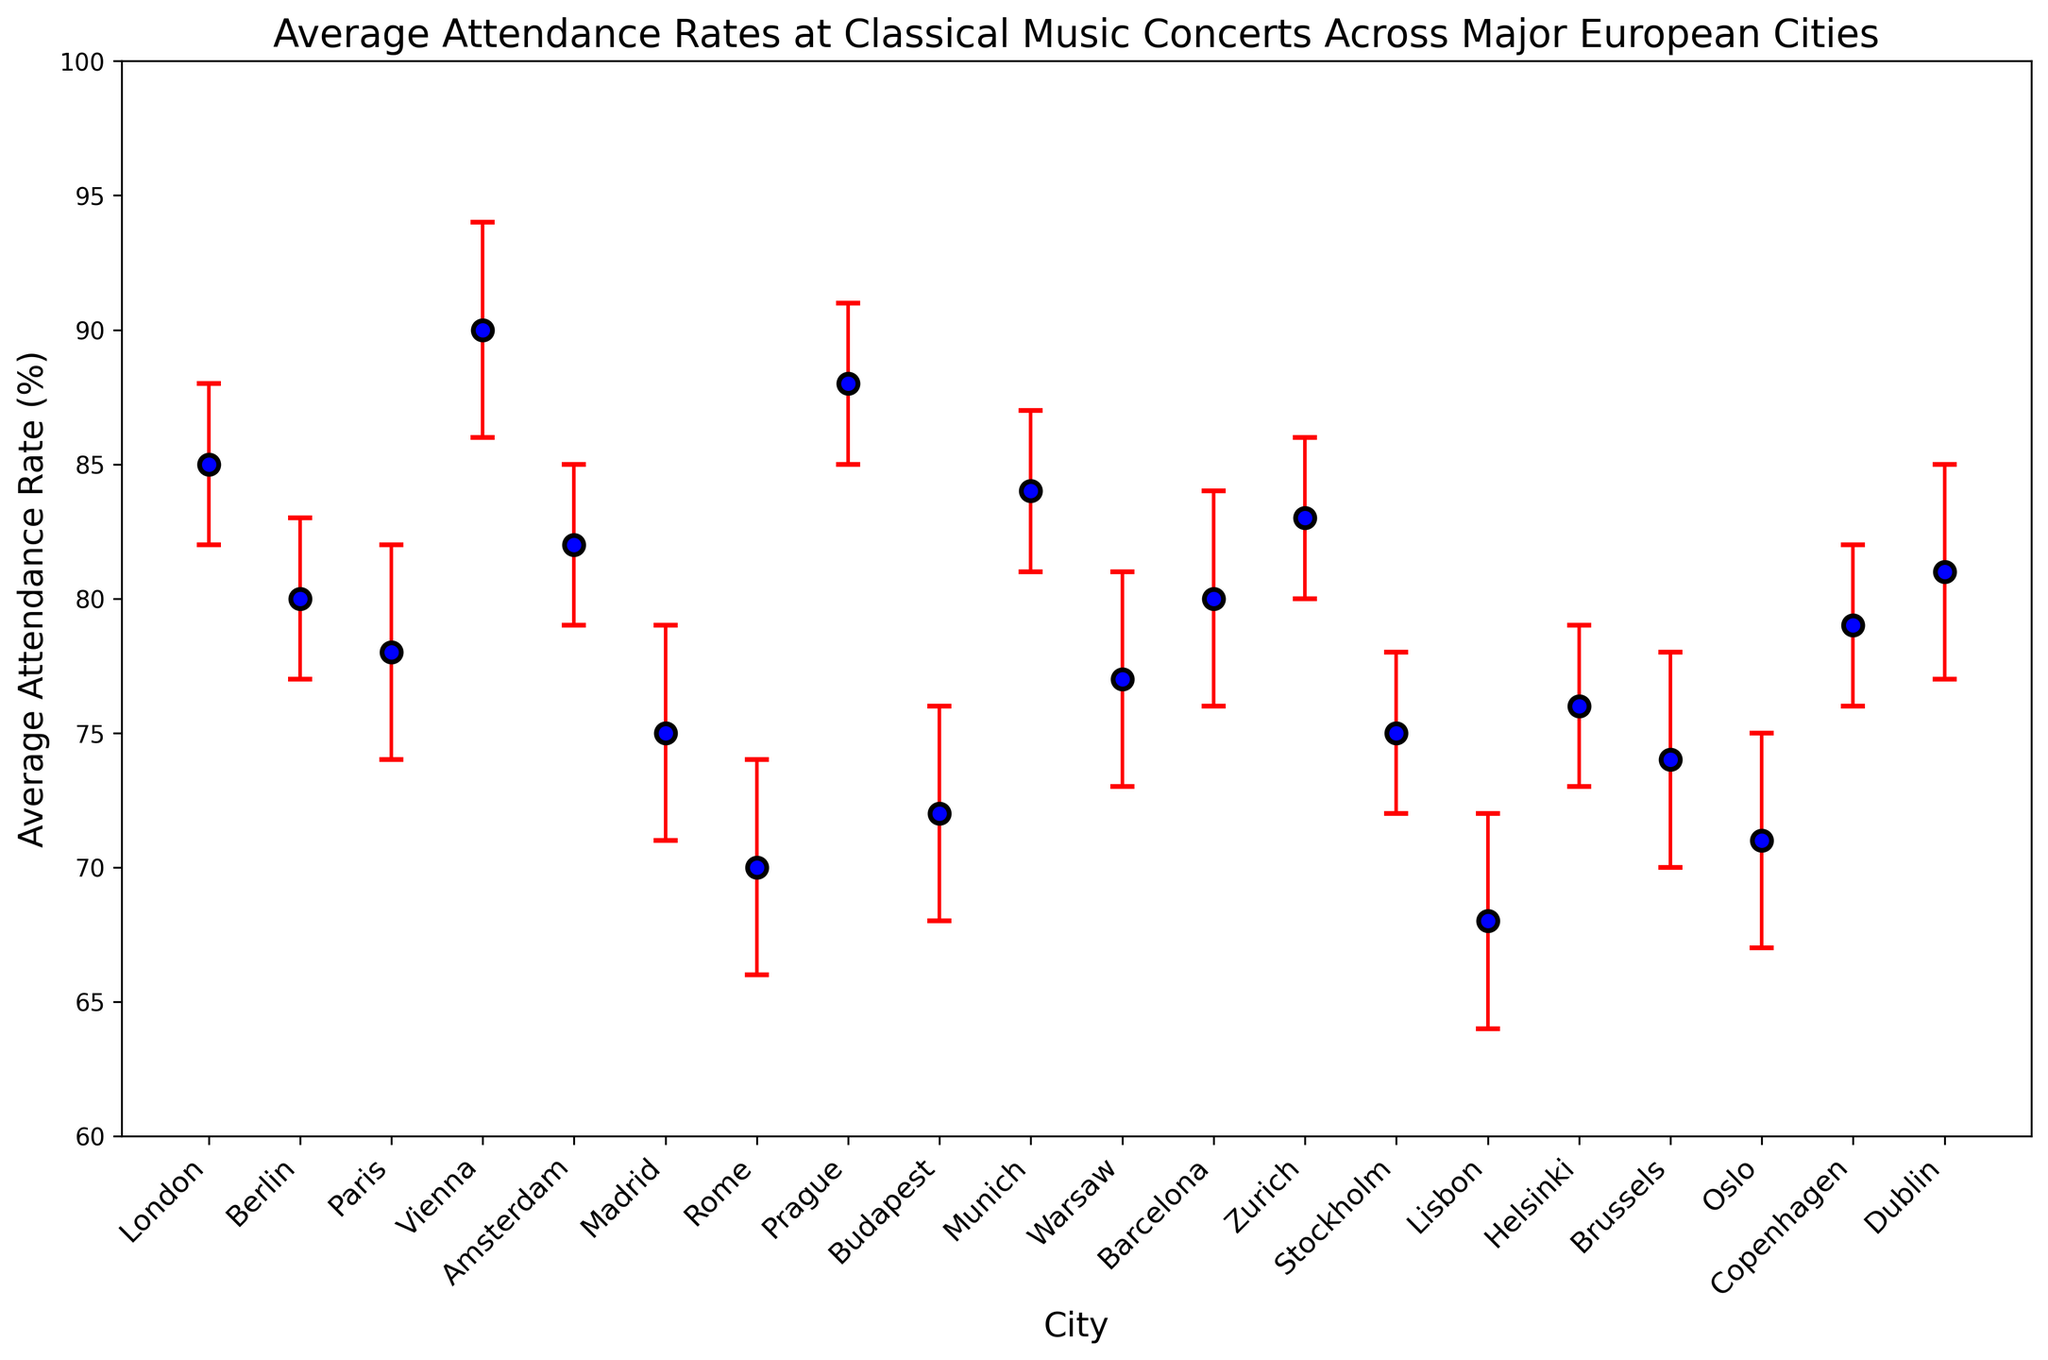Which city has the highest average attendance rate? Look at the data points for each city and identify the city with the tallest marker. Vienna has the highest average attendance rate.
Answer: Vienna Which city has the lowest average attendance rate? Locate the city with the shortest marker on the plot. Lisbon has the lowest average attendance rate.
Answer: Lisbon What is the confidence interval for Helsinki? Refer to the error bars for Helsinki and note the lower and upper bounds. The confidence interval for Helsinki is from 73% to 79%.
Answer: 73% to 79% How does the average attendance rate in Prague compare to Berlin? Observe and compare the heights of the markers for Prague and Berlin. Prague has a higher average attendance rate (88%) compared to Berlin (80%).
Answer: Prague higher What is the difference in average attendance rates between Vienna and Budapest? Subtract the average attendance rate of Budapest from that of Vienna. Vienna's rate is 90%, and Budapest's is 72%, so the difference is 90% - 72% = 18%.
Answer: 18% Which cities have an average attendance rate of at least 80%? Identify the cities with average attendance rates meeting or exceeding 80%. The cities are London, Berlin, Vienna, Amsterdam, Prague, Munich, Zurich, Barcelona, Copenhagen, Dublin.
Answer: London, Berlin, Vienna, Amsterdam, Prague, Munich, Zurich, Barcelona, Copenhagen, Dublin What is the average of the lower bounds of the confidence intervals for Warsaw and Munich? Extract the lower bounds for Warsaw (73%) and Munich (81%) and calculate their average: (73% + 81%) / 2 = 77%.
Answer: 77% Which city has the widest confidence interval? Look for the error bars showing the largest range between the upper and lower bounds. Vienna's confidence interval ranges from 86% to 94%, which is 8%.
Answer: Vienna How many cities have an average attendance rate less than 75%? Count the cities with average attendance rates below 75%. There are four cities: Madrid, Rome, Budapest, and Lisbon.
Answer: 4 